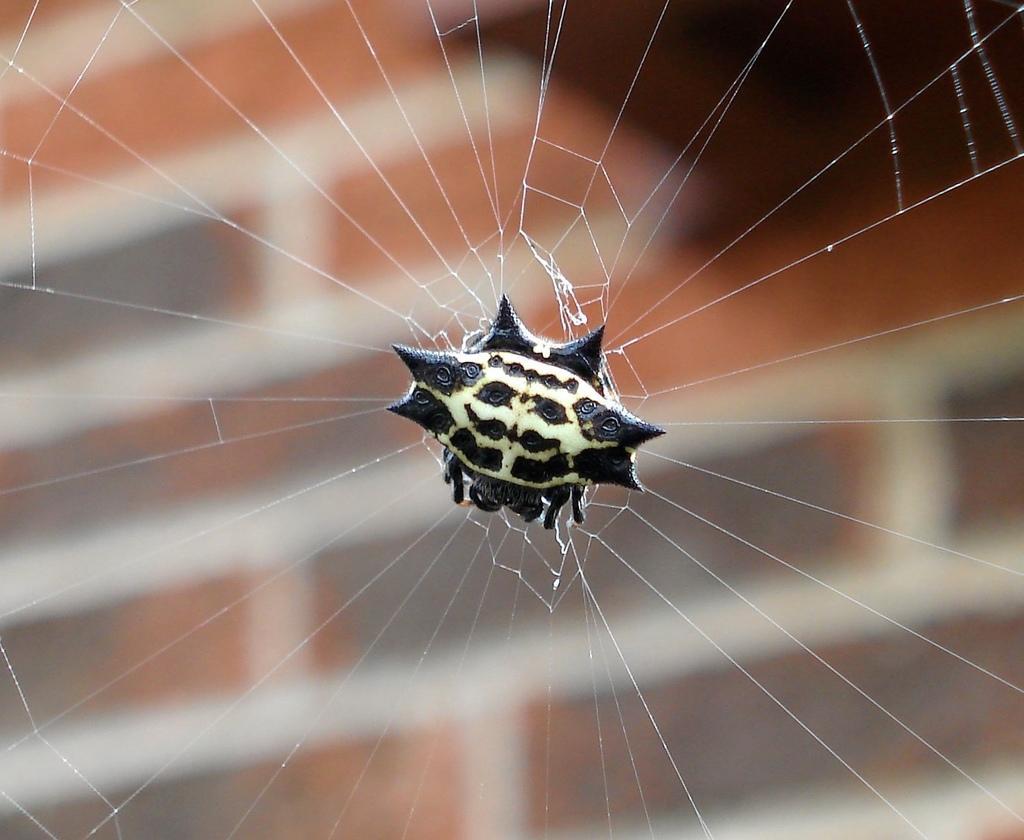Could you give a brief overview of what you see in this image? In this image we can see a spider and spider web. 